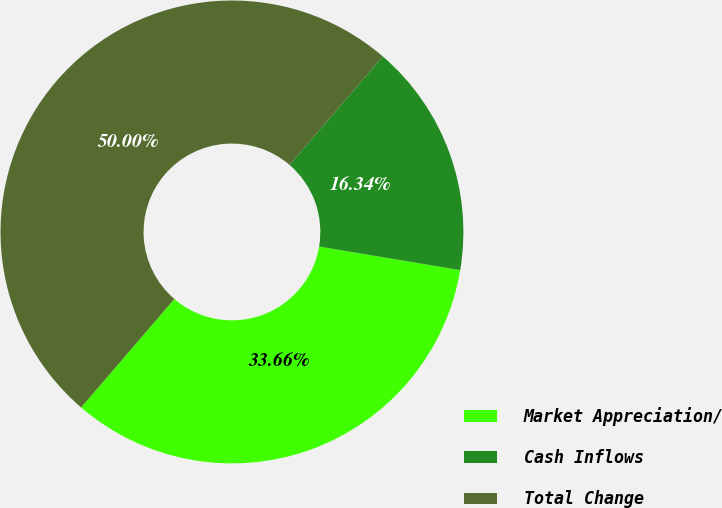Convert chart. <chart><loc_0><loc_0><loc_500><loc_500><pie_chart><fcel>Market Appreciation/<fcel>Cash Inflows<fcel>Total Change<nl><fcel>33.66%<fcel>16.34%<fcel>50.0%<nl></chart> 